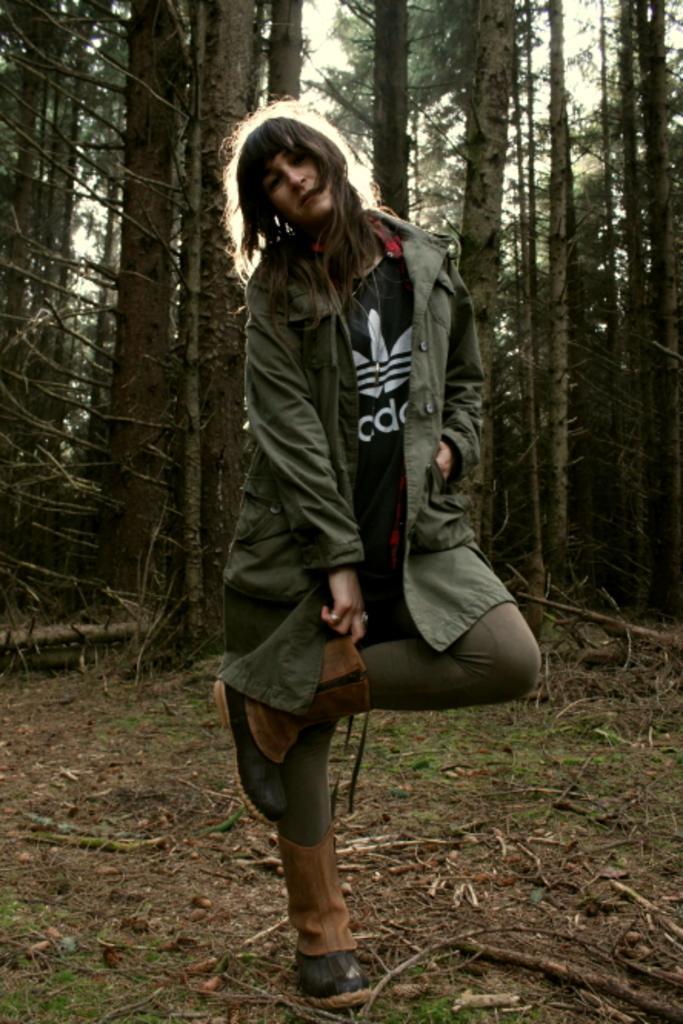How would you summarize this image in a sentence or two? This picture is clicked outside. In the center there is a person wearing a jacket and standing on the ground. In the background we can see the green grass, trees and the sky. 